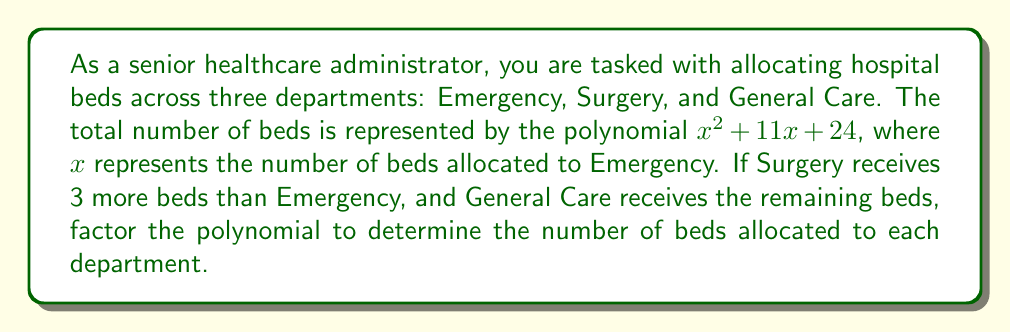Can you answer this question? Let's approach this step-by-step:

1) We're given that the total number of beds is represented by $x^2 + 11x + 24$

2) Let $x$ be the number of beds in Emergency
   Surgery gets $x + 3$ beds
   General Care gets the remaining beds

3) To factor this polynomial, we need to find two numbers that:
   - Multiply to give $24$ (the constant term)
   - Add up to $11$ (the coefficient of $x$)

4) The factors of 24 are: 1, 2, 3, 4, 6, 8, 12, 24
   By inspection, we can see that 3 and 8 satisfy both conditions:
   $3 \times 8 = 24$ and $3 + 8 = 11$

5) Therefore, we can factor the polynomial as:
   $$x^2 + 11x + 24 = (x + 3)(x + 8)$$

6) This factorization tells us:
   Emergency (x) + 3 = x + 3
   Emergency (x) + 8 = x + 8

7) Solving these:
   Emergency: $x = 5$ beds
   Surgery: $x + 3 = 5 + 3 = 8$ beds
   General Care: $x + 8 = 5 + 8 = 13$ beds

8) We can verify: $5 + 8 + 13 = 26$, which equals $5^2 + 11(5) + 24$
Answer: Emergency: 5 beds, Surgery: 8 beds, General Care: 13 beds 